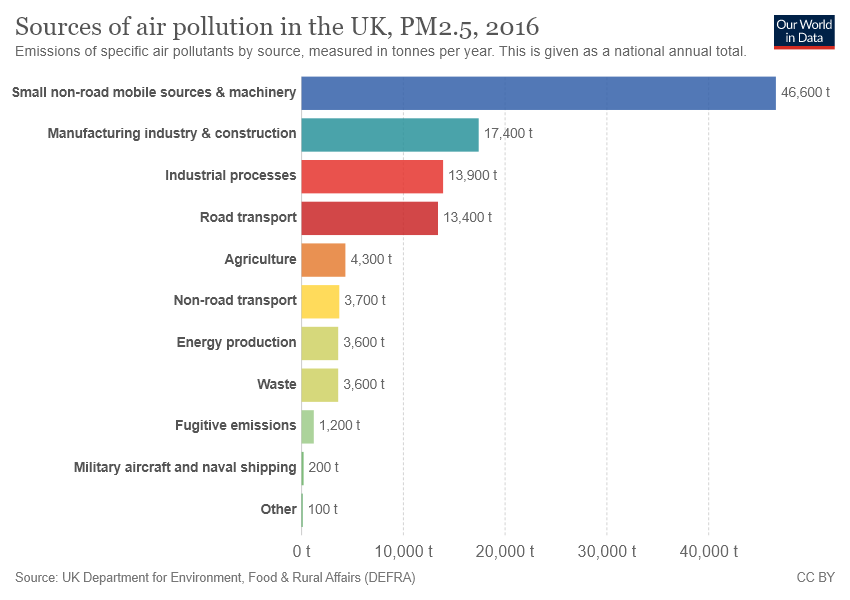Indicate a few pertinent items in this graphic. The sum of the smallest two bars is not equal to 1/3 times the value of the third smallest bar. The value of the largest bar is approximately 46,600. 